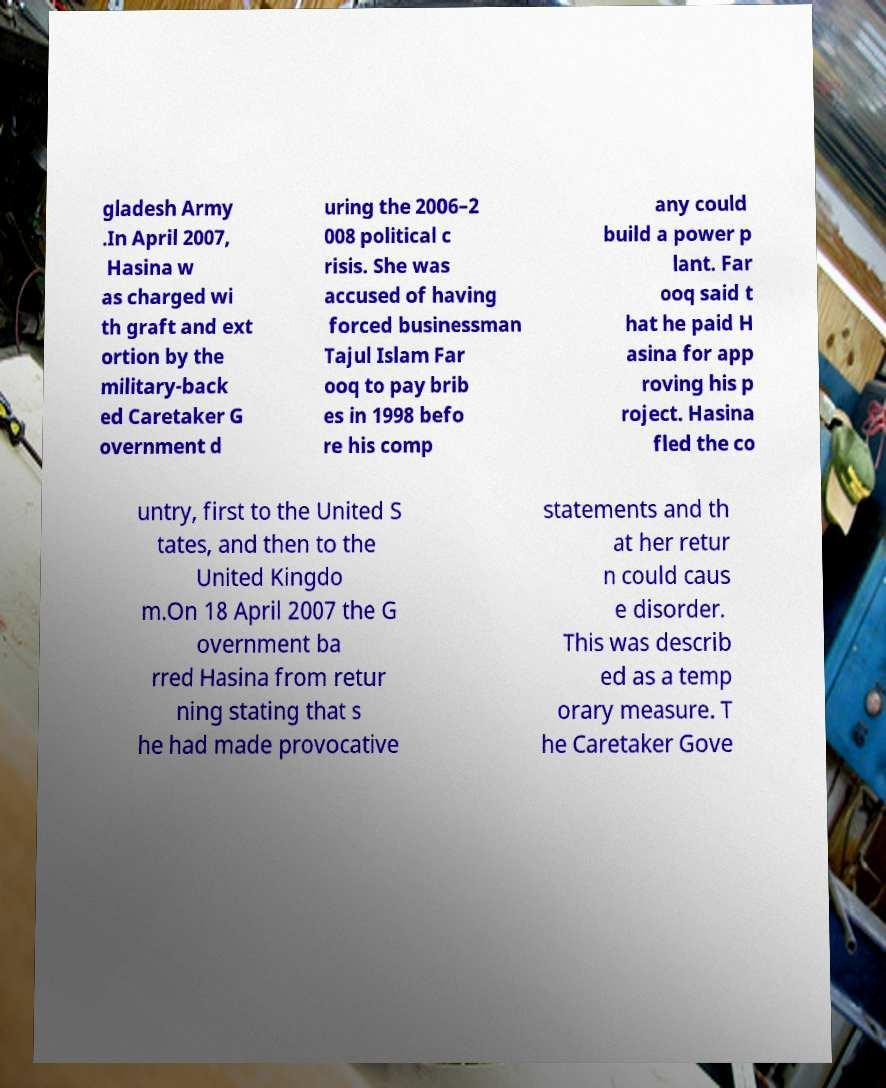There's text embedded in this image that I need extracted. Can you transcribe it verbatim? gladesh Army .In April 2007, Hasina w as charged wi th graft and ext ortion by the military-back ed Caretaker G overnment d uring the 2006–2 008 political c risis. She was accused of having forced businessman Tajul Islam Far ooq to pay brib es in 1998 befo re his comp any could build a power p lant. Far ooq said t hat he paid H asina for app roving his p roject. Hasina fled the co untry, first to the United S tates, and then to the United Kingdo m.On 18 April 2007 the G overnment ba rred Hasina from retur ning stating that s he had made provocative statements and th at her retur n could caus e disorder. This was describ ed as a temp orary measure. T he Caretaker Gove 